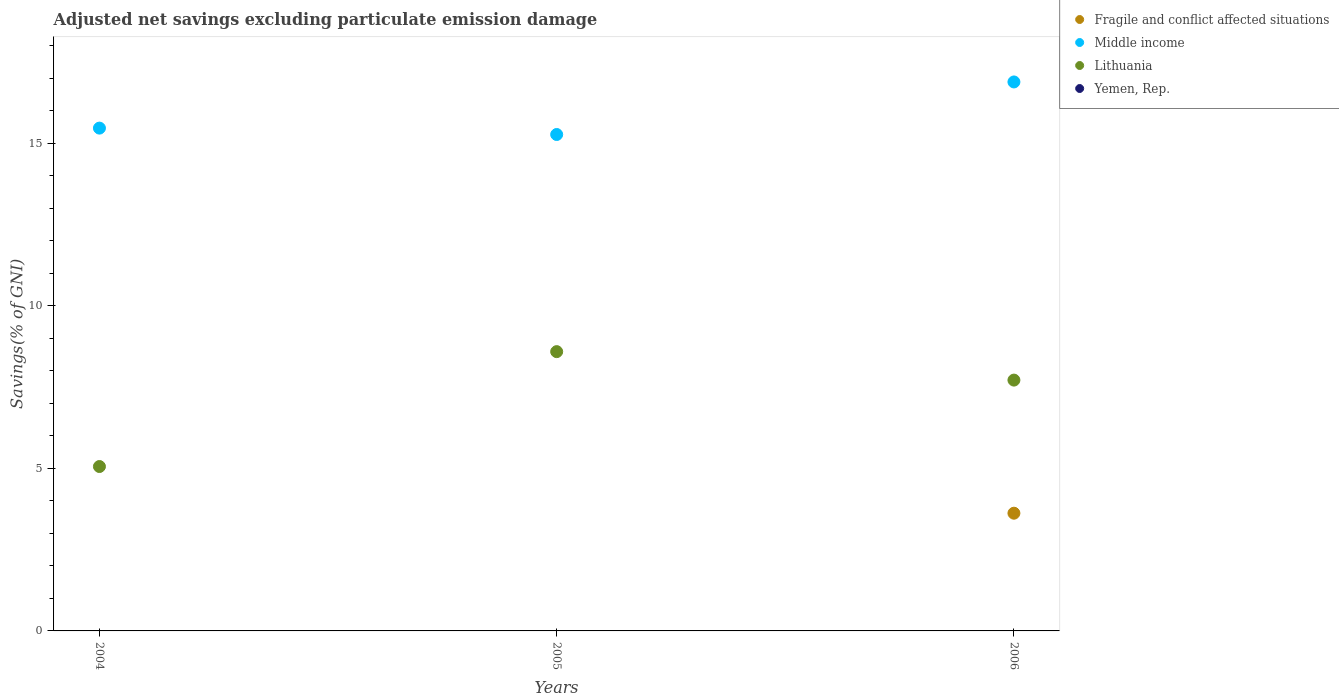How many different coloured dotlines are there?
Your response must be concise. 3. Across all years, what is the maximum adjusted net savings in Lithuania?
Your answer should be compact. 8.59. Across all years, what is the minimum adjusted net savings in Lithuania?
Your answer should be compact. 5.06. In which year was the adjusted net savings in Fragile and conflict affected situations maximum?
Your response must be concise. 2006. What is the total adjusted net savings in Middle income in the graph?
Provide a succinct answer. 47.63. What is the difference between the adjusted net savings in Middle income in 2005 and that in 2006?
Ensure brevity in your answer.  -1.62. What is the difference between the adjusted net savings in Lithuania in 2006 and the adjusted net savings in Yemen, Rep. in 2005?
Keep it short and to the point. 7.72. What is the average adjusted net savings in Middle income per year?
Provide a succinct answer. 15.88. In how many years, is the adjusted net savings in Lithuania greater than 9 %?
Provide a succinct answer. 0. What is the ratio of the adjusted net savings in Middle income in 2004 to that in 2006?
Provide a succinct answer. 0.92. Is the adjusted net savings in Lithuania in 2004 less than that in 2006?
Your response must be concise. Yes. What is the difference between the highest and the second highest adjusted net savings in Middle income?
Provide a succinct answer. 1.42. What is the difference between the highest and the lowest adjusted net savings in Fragile and conflict affected situations?
Your response must be concise. 3.62. Is the sum of the adjusted net savings in Middle income in 2005 and 2006 greater than the maximum adjusted net savings in Fragile and conflict affected situations across all years?
Give a very brief answer. Yes. Is it the case that in every year, the sum of the adjusted net savings in Fragile and conflict affected situations and adjusted net savings in Yemen, Rep.  is greater than the adjusted net savings in Middle income?
Give a very brief answer. No. Does the adjusted net savings in Fragile and conflict affected situations monotonically increase over the years?
Provide a short and direct response. Yes. Is the adjusted net savings in Fragile and conflict affected situations strictly greater than the adjusted net savings in Lithuania over the years?
Your answer should be very brief. No. Is the adjusted net savings in Yemen, Rep. strictly less than the adjusted net savings in Lithuania over the years?
Give a very brief answer. Yes. How many years are there in the graph?
Your response must be concise. 3. What is the difference between two consecutive major ticks on the Y-axis?
Provide a succinct answer. 5. Are the values on the major ticks of Y-axis written in scientific E-notation?
Offer a terse response. No. How many legend labels are there?
Your answer should be compact. 4. How are the legend labels stacked?
Keep it short and to the point. Vertical. What is the title of the graph?
Your answer should be very brief. Adjusted net savings excluding particulate emission damage. Does "American Samoa" appear as one of the legend labels in the graph?
Provide a short and direct response. No. What is the label or title of the Y-axis?
Ensure brevity in your answer.  Savings(% of GNI). What is the Savings(% of GNI) of Fragile and conflict affected situations in 2004?
Offer a very short reply. 0. What is the Savings(% of GNI) of Middle income in 2004?
Your answer should be compact. 15.47. What is the Savings(% of GNI) in Lithuania in 2004?
Your answer should be compact. 5.06. What is the Savings(% of GNI) in Middle income in 2005?
Offer a terse response. 15.27. What is the Savings(% of GNI) in Lithuania in 2005?
Your answer should be compact. 8.59. What is the Savings(% of GNI) in Fragile and conflict affected situations in 2006?
Ensure brevity in your answer.  3.62. What is the Savings(% of GNI) in Middle income in 2006?
Keep it short and to the point. 16.89. What is the Savings(% of GNI) of Lithuania in 2006?
Keep it short and to the point. 7.72. What is the Savings(% of GNI) in Yemen, Rep. in 2006?
Keep it short and to the point. 0. Across all years, what is the maximum Savings(% of GNI) of Fragile and conflict affected situations?
Ensure brevity in your answer.  3.62. Across all years, what is the maximum Savings(% of GNI) in Middle income?
Your response must be concise. 16.89. Across all years, what is the maximum Savings(% of GNI) in Lithuania?
Provide a short and direct response. 8.59. Across all years, what is the minimum Savings(% of GNI) in Fragile and conflict affected situations?
Provide a short and direct response. 0. Across all years, what is the minimum Savings(% of GNI) of Middle income?
Provide a short and direct response. 15.27. Across all years, what is the minimum Savings(% of GNI) of Lithuania?
Your response must be concise. 5.06. What is the total Savings(% of GNI) in Fragile and conflict affected situations in the graph?
Keep it short and to the point. 3.62. What is the total Savings(% of GNI) in Middle income in the graph?
Keep it short and to the point. 47.63. What is the total Savings(% of GNI) of Lithuania in the graph?
Your response must be concise. 21.37. What is the total Savings(% of GNI) of Yemen, Rep. in the graph?
Offer a very short reply. 0. What is the difference between the Savings(% of GNI) of Middle income in 2004 and that in 2005?
Provide a succinct answer. 0.2. What is the difference between the Savings(% of GNI) in Lithuania in 2004 and that in 2005?
Your answer should be very brief. -3.53. What is the difference between the Savings(% of GNI) of Middle income in 2004 and that in 2006?
Your answer should be very brief. -1.42. What is the difference between the Savings(% of GNI) in Lithuania in 2004 and that in 2006?
Ensure brevity in your answer.  -2.66. What is the difference between the Savings(% of GNI) of Middle income in 2005 and that in 2006?
Keep it short and to the point. -1.62. What is the difference between the Savings(% of GNI) of Lithuania in 2005 and that in 2006?
Give a very brief answer. 0.88. What is the difference between the Savings(% of GNI) in Middle income in 2004 and the Savings(% of GNI) in Lithuania in 2005?
Make the answer very short. 6.88. What is the difference between the Savings(% of GNI) in Middle income in 2004 and the Savings(% of GNI) in Lithuania in 2006?
Ensure brevity in your answer.  7.75. What is the difference between the Savings(% of GNI) in Middle income in 2005 and the Savings(% of GNI) in Lithuania in 2006?
Your answer should be very brief. 7.56. What is the average Savings(% of GNI) in Fragile and conflict affected situations per year?
Your answer should be compact. 1.21. What is the average Savings(% of GNI) of Middle income per year?
Give a very brief answer. 15.88. What is the average Savings(% of GNI) in Lithuania per year?
Make the answer very short. 7.12. In the year 2004, what is the difference between the Savings(% of GNI) in Middle income and Savings(% of GNI) in Lithuania?
Provide a succinct answer. 10.41. In the year 2005, what is the difference between the Savings(% of GNI) in Middle income and Savings(% of GNI) in Lithuania?
Ensure brevity in your answer.  6.68. In the year 2006, what is the difference between the Savings(% of GNI) in Fragile and conflict affected situations and Savings(% of GNI) in Middle income?
Give a very brief answer. -13.27. In the year 2006, what is the difference between the Savings(% of GNI) of Fragile and conflict affected situations and Savings(% of GNI) of Lithuania?
Keep it short and to the point. -4.1. In the year 2006, what is the difference between the Savings(% of GNI) of Middle income and Savings(% of GNI) of Lithuania?
Provide a short and direct response. 9.17. What is the ratio of the Savings(% of GNI) in Middle income in 2004 to that in 2005?
Offer a very short reply. 1.01. What is the ratio of the Savings(% of GNI) of Lithuania in 2004 to that in 2005?
Give a very brief answer. 0.59. What is the ratio of the Savings(% of GNI) of Middle income in 2004 to that in 2006?
Keep it short and to the point. 0.92. What is the ratio of the Savings(% of GNI) of Lithuania in 2004 to that in 2006?
Your answer should be very brief. 0.66. What is the ratio of the Savings(% of GNI) in Middle income in 2005 to that in 2006?
Keep it short and to the point. 0.9. What is the ratio of the Savings(% of GNI) in Lithuania in 2005 to that in 2006?
Provide a succinct answer. 1.11. What is the difference between the highest and the second highest Savings(% of GNI) in Middle income?
Give a very brief answer. 1.42. What is the difference between the highest and the second highest Savings(% of GNI) of Lithuania?
Your answer should be compact. 0.88. What is the difference between the highest and the lowest Savings(% of GNI) in Fragile and conflict affected situations?
Offer a very short reply. 3.62. What is the difference between the highest and the lowest Savings(% of GNI) of Middle income?
Your answer should be compact. 1.62. What is the difference between the highest and the lowest Savings(% of GNI) of Lithuania?
Your response must be concise. 3.53. 